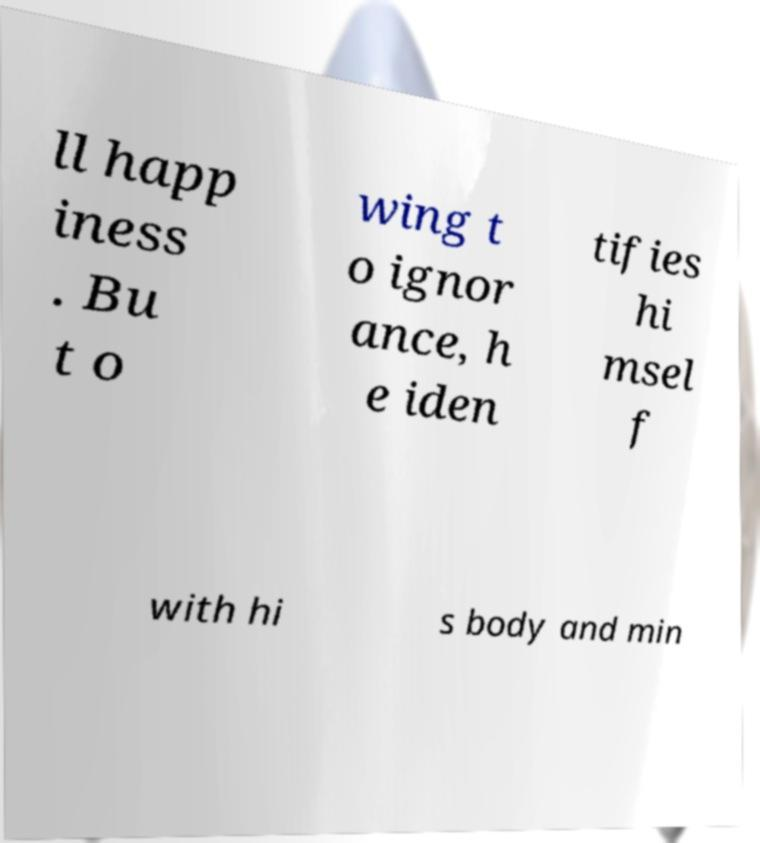Please identify and transcribe the text found in this image. ll happ iness . Bu t o wing t o ignor ance, h e iden tifies hi msel f with hi s body and min 